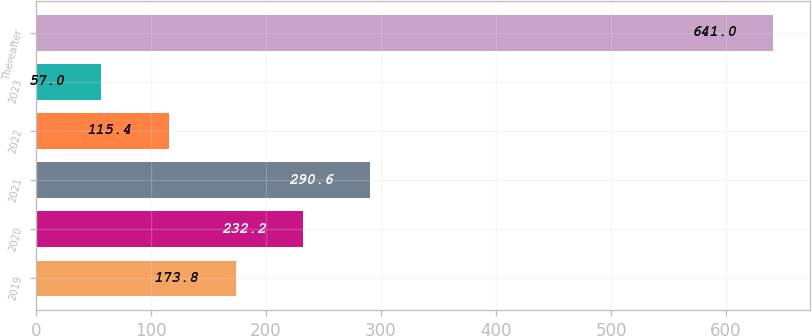Convert chart to OTSL. <chart><loc_0><loc_0><loc_500><loc_500><bar_chart><fcel>2019<fcel>2020<fcel>2021<fcel>2022<fcel>2023<fcel>Thereafter<nl><fcel>173.8<fcel>232.2<fcel>290.6<fcel>115.4<fcel>57<fcel>641<nl></chart> 